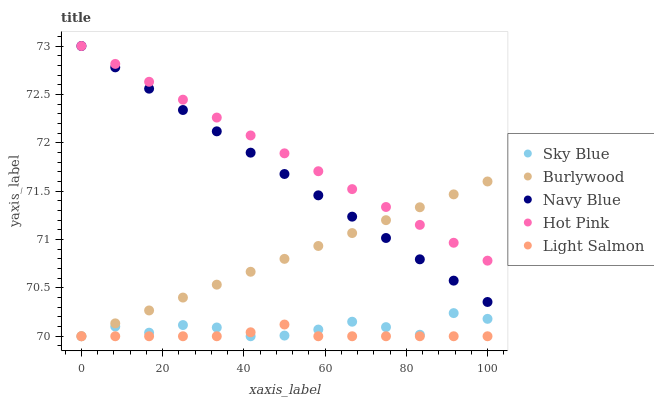Does Light Salmon have the minimum area under the curve?
Answer yes or no. Yes. Does Hot Pink have the maximum area under the curve?
Answer yes or no. Yes. Does Sky Blue have the minimum area under the curve?
Answer yes or no. No. Does Sky Blue have the maximum area under the curve?
Answer yes or no. No. Is Hot Pink the smoothest?
Answer yes or no. Yes. Is Sky Blue the roughest?
Answer yes or no. Yes. Is Light Salmon the smoothest?
Answer yes or no. No. Is Light Salmon the roughest?
Answer yes or no. No. Does Burlywood have the lowest value?
Answer yes or no. Yes. Does Hot Pink have the lowest value?
Answer yes or no. No. Does Navy Blue have the highest value?
Answer yes or no. Yes. Does Sky Blue have the highest value?
Answer yes or no. No. Is Sky Blue less than Hot Pink?
Answer yes or no. Yes. Is Hot Pink greater than Sky Blue?
Answer yes or no. Yes. Does Light Salmon intersect Burlywood?
Answer yes or no. Yes. Is Light Salmon less than Burlywood?
Answer yes or no. No. Is Light Salmon greater than Burlywood?
Answer yes or no. No. Does Sky Blue intersect Hot Pink?
Answer yes or no. No. 